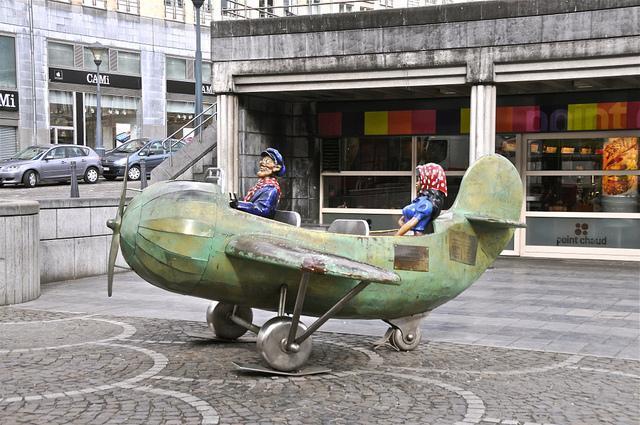How many people are in the plane?
Give a very brief answer. 2. 